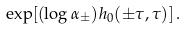<formula> <loc_0><loc_0><loc_500><loc_500>\exp [ ( \log \alpha _ { \pm } ) h _ { 0 } ( \pm \tau , \tau ) ] \, .</formula> 